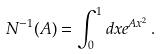<formula> <loc_0><loc_0><loc_500><loc_500>N ^ { - 1 } ( A ) = \int _ { 0 } ^ { 1 } d x e ^ { A x ^ { 2 } } \, .</formula> 